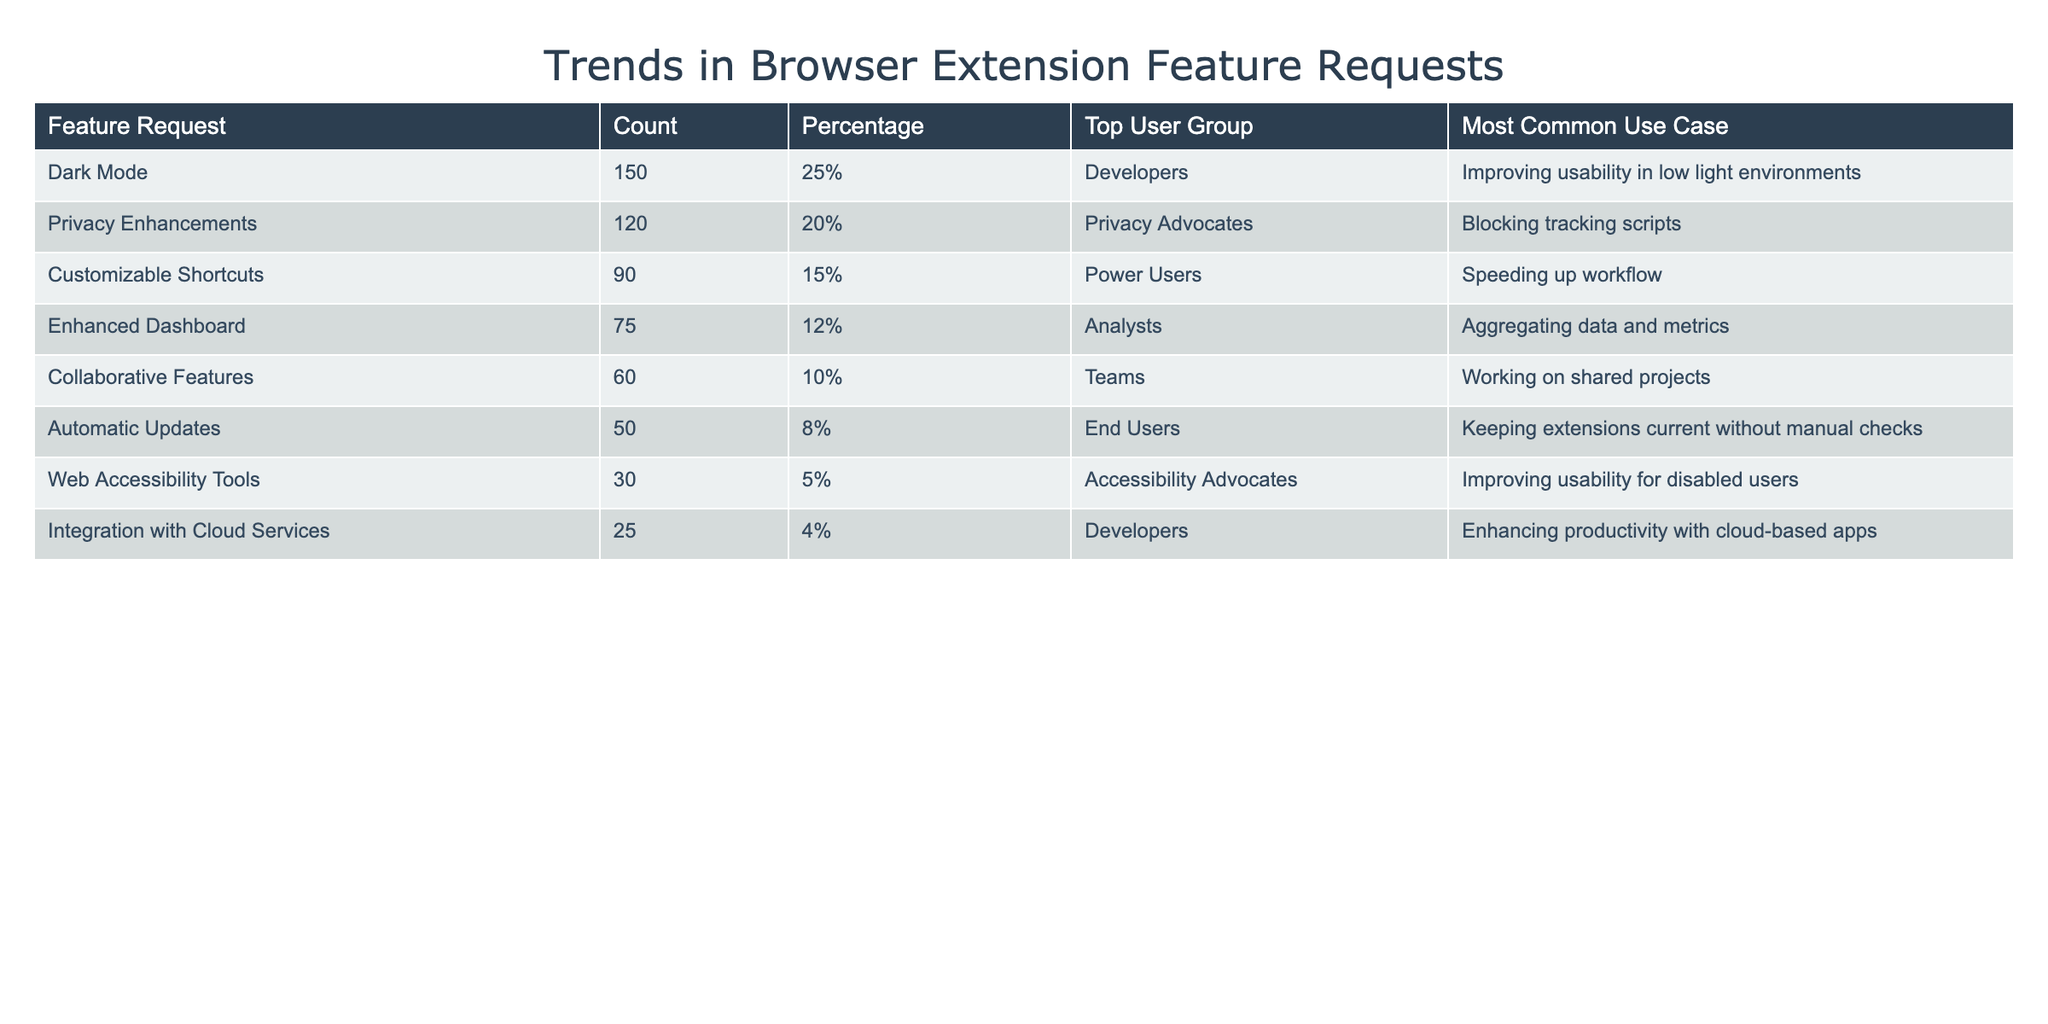What is the feature request with the highest count? The feature request with the highest count is "Dark Mode," which has a count of 150. This can be directly seen in the "Count" column of the table.
Answer: Dark Mode Which user group is most associated with "Privacy Enhancements"? The user group most associated with "Privacy Enhancements" is "Privacy Advocates." This information is listed in the "Top User Group" column for that specific feature request.
Answer: Privacy Advocates What percentage of total requests do "Automatic Updates" account for? "Automatic Updates" account for 8% of the total requests. This percentage is given in the "Percentage" column next to that feature request in the table.
Answer: 8% How many requests were made for "Collaborative Features" and "Web Accessibility Tools" combined? To find the combined requests for these two features, we add their counts: "Collaborative Features" has 60 requests and "Web Accessibility Tools" has 30 requests. So, 60 + 30 = 90.
Answer: 90 Is "Enhanced Dashboard" the only feature with a count greater than 70? No, "Enhanced Dashboard" is not the only feature with a count greater than 70; "Dark Mode" and "Privacy Enhancements" also have counts greater than 70. We see counts of 150 and 120 respectively, while "Enhanced Dashboard" has 75, making it not unique in this regard.
Answer: No Which user group has the least number of requests, and what are the specific requests? The user group with the least number of requests is "Developers" concerning "Integration with Cloud Services," which has a count of 25. This can be found in the "Top User Group" column, corresponding to the least count in the "Count" column for those specific requests.
Answer: Developers - Integration with Cloud Services What is the average percentage of requests for the top three feature requests? The average percentage for the top three feature requests is calculated by adding their percentages: 25% + 20% + 15% = 60%. There are three requests, so the average is 60% / 3 = 20%.
Answer: 20% Which use case is most common for "Customizable Shortcuts"? The most common use case for "Customizable Shortcuts" is "Speeding up workflow." This information is found in the "Most Common Use Case" column corresponding to that feature request.
Answer: Speeding up workflow 